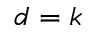Convert formula to latex. <formula><loc_0><loc_0><loc_500><loc_500>d = k</formula> 